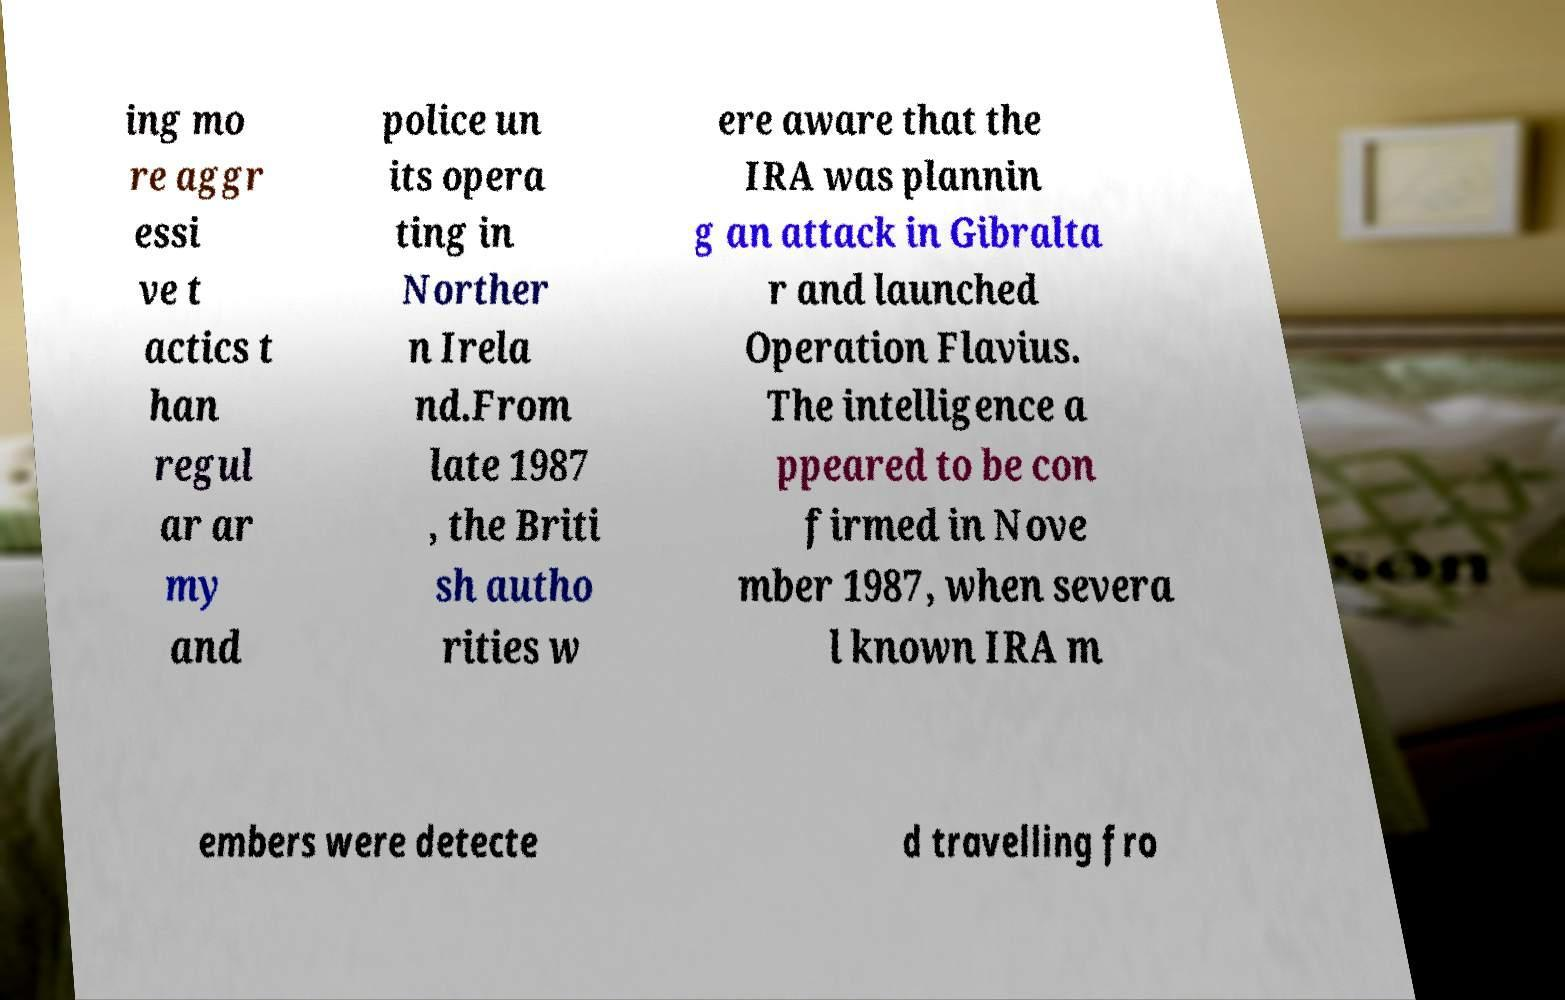Can you read and provide the text displayed in the image?This photo seems to have some interesting text. Can you extract and type it out for me? ing mo re aggr essi ve t actics t han regul ar ar my and police un its opera ting in Norther n Irela nd.From late 1987 , the Briti sh autho rities w ere aware that the IRA was plannin g an attack in Gibralta r and launched Operation Flavius. The intelligence a ppeared to be con firmed in Nove mber 1987, when severa l known IRA m embers were detecte d travelling fro 